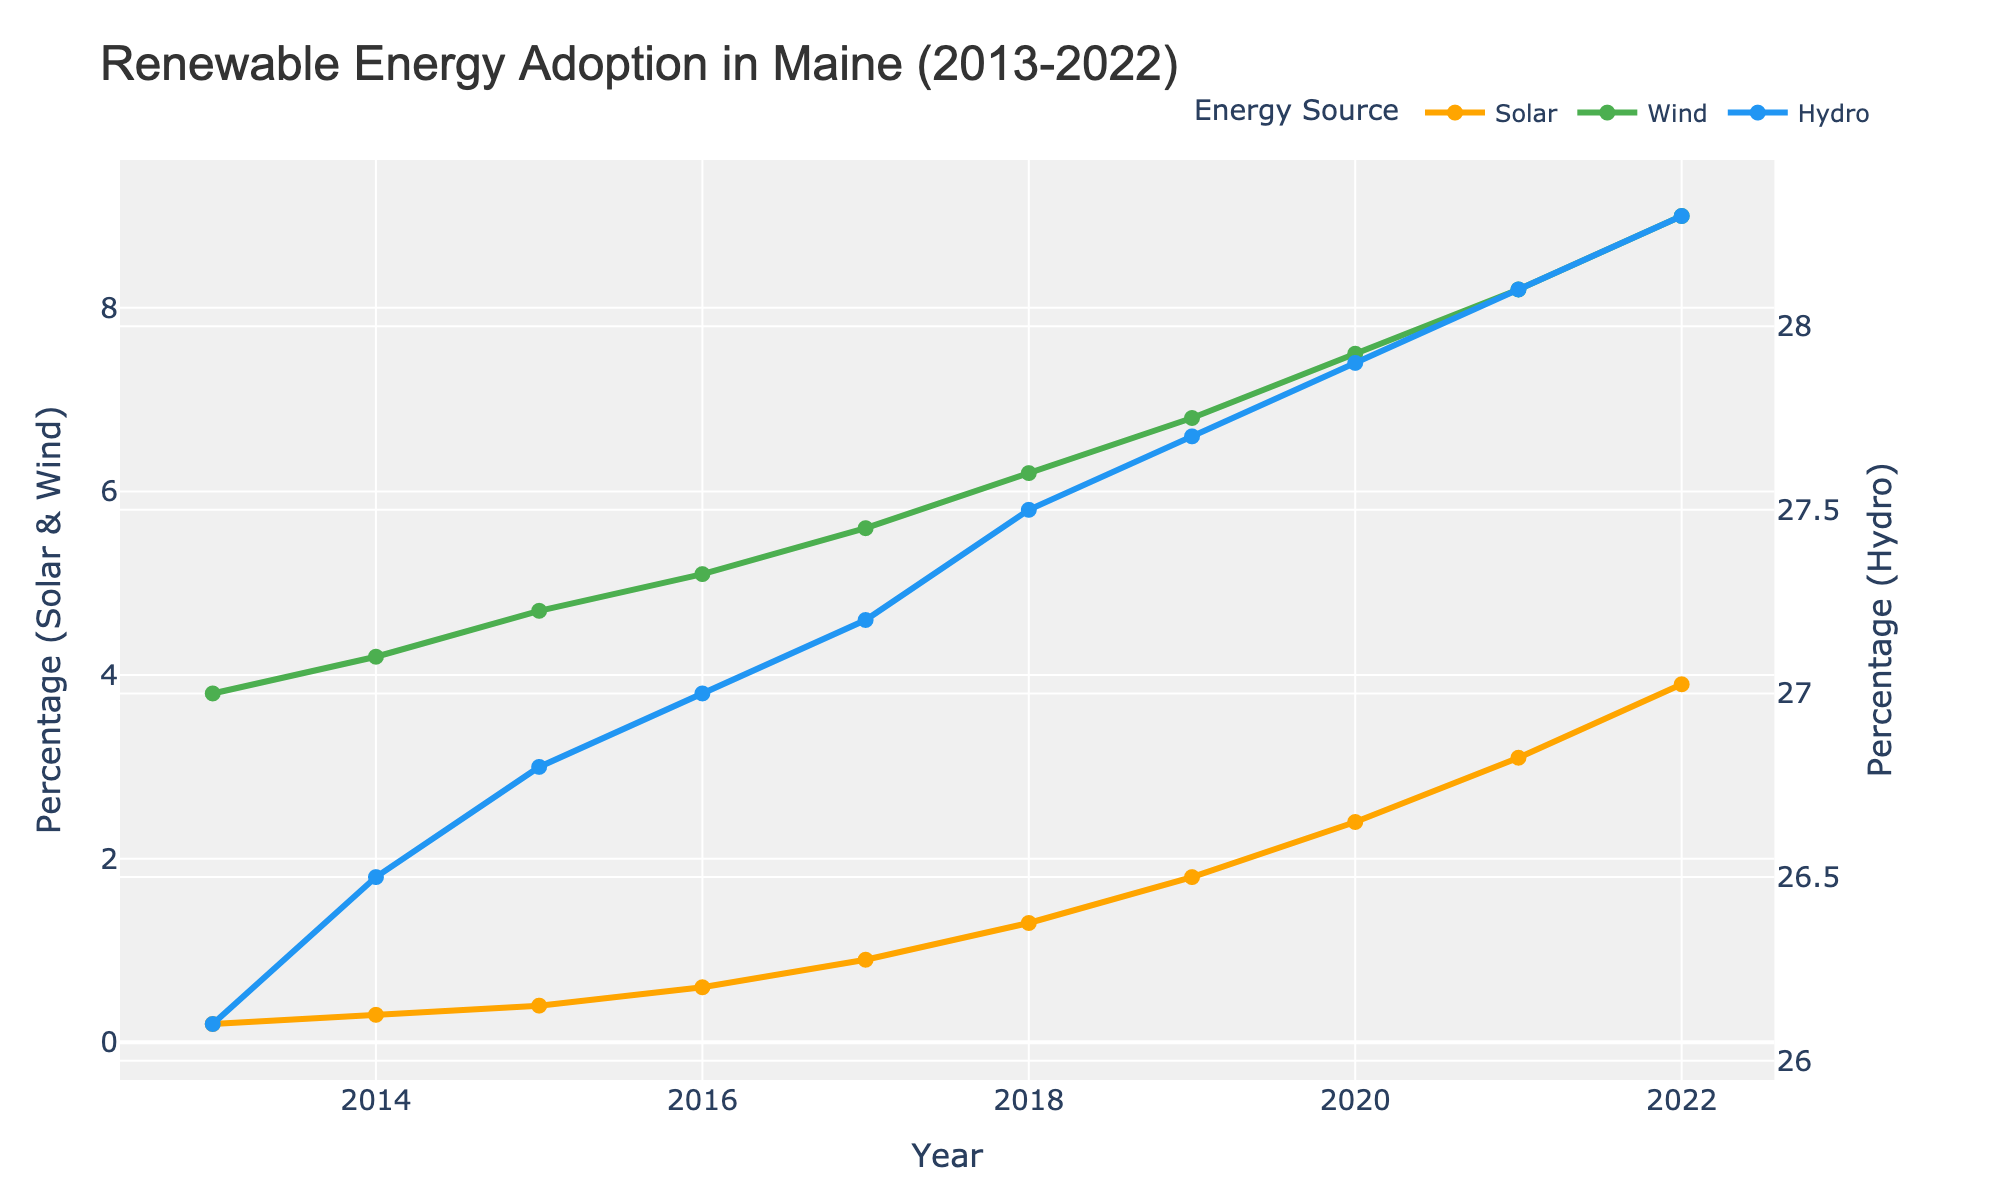What's the overall trend for solar energy adoption from 2013 to 2022? The solar energy adoption rate increases each year based on the line's upward slope. The value starts at 0.2% in 2013 and reaches 3.9% in 2022.
Answer: Increasing In which year did wind energy adoption first exceed 6%? The wind energy adoption rate first exceeds 6% in 2018. By looking at the corresponding year where the wind line crosses the 6% mark, we see it is 2018.
Answer: 2018 How does hydro energy adoption compare to wind energy adoption in 2020? In 2020, hydro energy adoption is approximately 27.9%, and wind energy adoption is 7.5%. Hydro energy adoption is much higher than wind energy adoption in 2020.
Answer: Hydro is much higher Which energy source had the steepest increase in adoption from 2013 to 2022? The slope of the lines indicates the rate of increase. Solar energy shows the steepest increase, with its adoption rate rising from 0.2% to 3.9%, a difference of 3.7%.
Answer: Solar What is the difference in hydro energy adoption between 2015 and 2022? Hydro energy adoption in 2015 is 26.8%, and in 2022 it's 28.3%. The difference is 28.3% - 26.8% = 1.5%.
Answer: 1.5% Which year had the highest adoption rate for each energy source? Each peak in the lines represents the highest adoption rate for each source. In 2022, Solar is at 3.9%, Wind at 9.0%, and Hydro at 28.3%.
Answer: 2022 Compare the growth rates of solar and wind energy from 2014 to 2018. Solar grows from 0.3% to 1.3%, a 1.0% increase. Wind grows from 4.2% to 6.2%, a 2.0% increase. Wind has a higher growth rate.
Answer: Wind has higher growth Which energy source shows the least variation in adoption rates over the period 2013 to 2022? Hydro energy's line is much flatter compared to solar and wind, showing the least change in adoption rates.
Answer: Hydro What's the sum of solar and wind energy adoption rates in 2019? In 2019, solar adoption is 1.8%, and wind adoption is 6.8%. Their sum is 1.8% + 6.8% = 8.6%.
Answer: 8.6% 